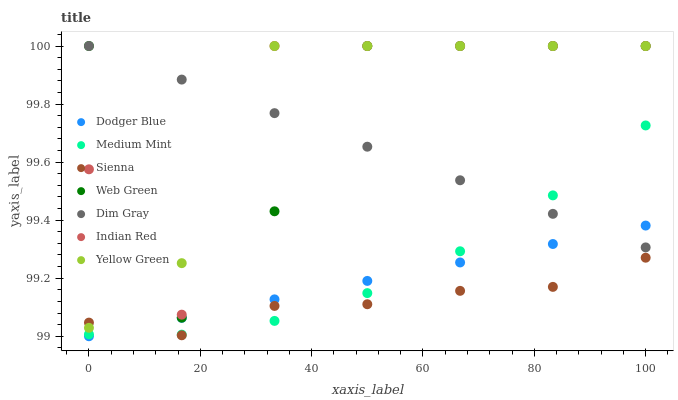Does Sienna have the minimum area under the curve?
Answer yes or no. Yes. Does Indian Red have the maximum area under the curve?
Answer yes or no. Yes. Does Dim Gray have the minimum area under the curve?
Answer yes or no. No. Does Dim Gray have the maximum area under the curve?
Answer yes or no. No. Is Dodger Blue the smoothest?
Answer yes or no. Yes. Is Indian Red the roughest?
Answer yes or no. Yes. Is Dim Gray the smoothest?
Answer yes or no. No. Is Dim Gray the roughest?
Answer yes or no. No. Does Dodger Blue have the lowest value?
Answer yes or no. Yes. Does Yellow Green have the lowest value?
Answer yes or no. No. Does Indian Red have the highest value?
Answer yes or no. Yes. Does Sienna have the highest value?
Answer yes or no. No. Is Medium Mint less than Yellow Green?
Answer yes or no. Yes. Is Indian Red greater than Dodger Blue?
Answer yes or no. Yes. Does Dim Gray intersect Yellow Green?
Answer yes or no. Yes. Is Dim Gray less than Yellow Green?
Answer yes or no. No. Is Dim Gray greater than Yellow Green?
Answer yes or no. No. Does Medium Mint intersect Yellow Green?
Answer yes or no. No. 